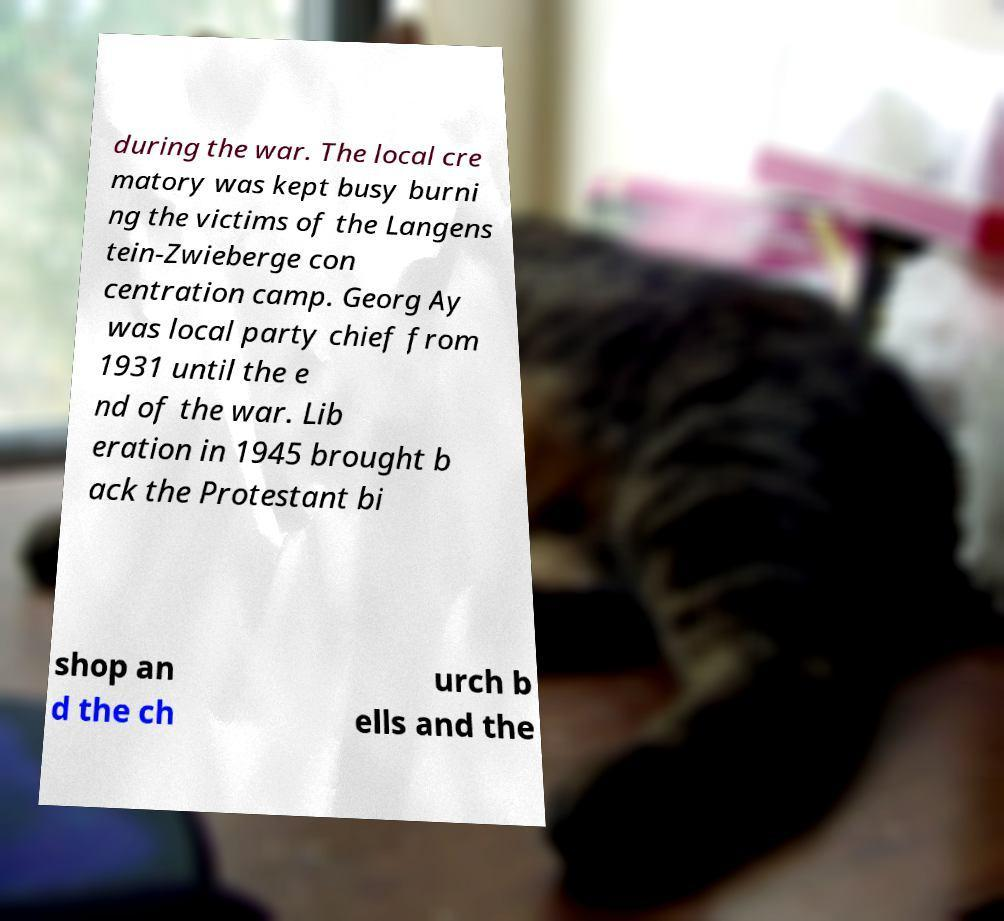What messages or text are displayed in this image? I need them in a readable, typed format. during the war. The local cre matory was kept busy burni ng the victims of the Langens tein-Zwieberge con centration camp. Georg Ay was local party chief from 1931 until the e nd of the war. Lib eration in 1945 brought b ack the Protestant bi shop an d the ch urch b ells and the 